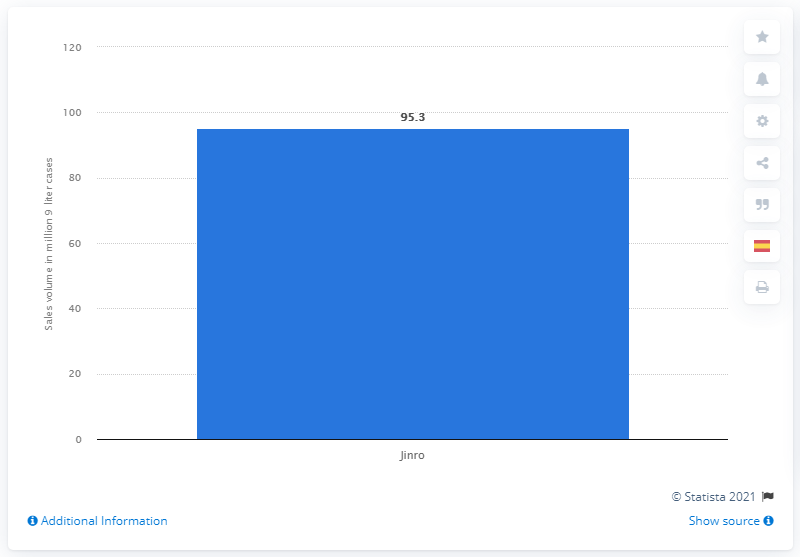Identify some key points in this picture. In 2020, Jinro's sales volume was 95.3%. Jinro was the leading Korean soju brand in 2020. 